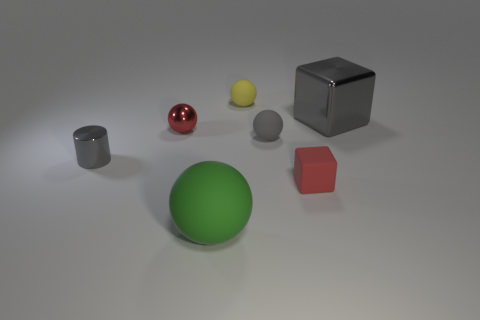Subtract all gray blocks. Subtract all red spheres. How many blocks are left? 1 Subtract all yellow cylinders. How many blue balls are left? 0 Add 1 reds. How many tiny objects exist? 0 Subtract all tiny yellow objects. Subtract all gray blocks. How many objects are left? 5 Add 1 yellow matte things. How many yellow matte things are left? 2 Add 2 gray things. How many gray things exist? 5 Add 2 large red rubber cylinders. How many objects exist? 9 Subtract all red balls. How many balls are left? 3 Subtract all gray spheres. How many spheres are left? 3 Subtract 0 purple blocks. How many objects are left? 7 